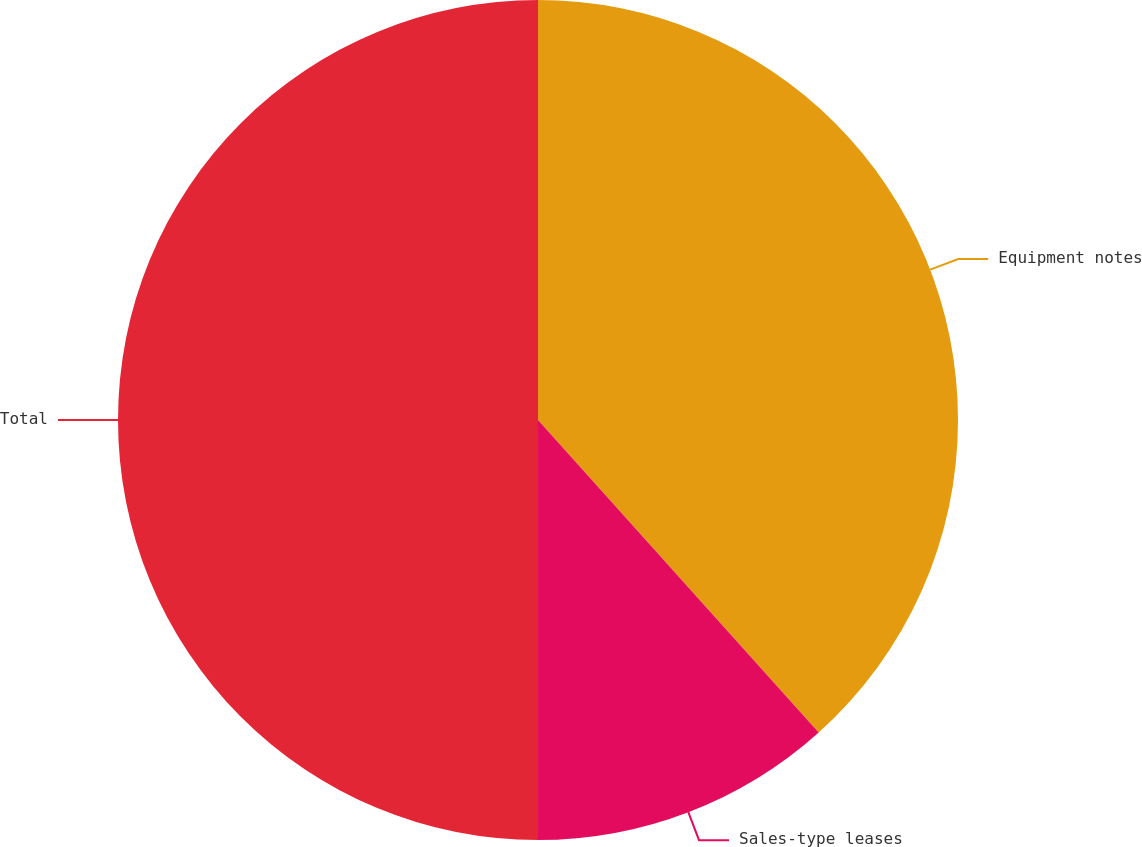Convert chart. <chart><loc_0><loc_0><loc_500><loc_500><pie_chart><fcel>Equipment notes<fcel>Sales-type leases<fcel>Total<nl><fcel>38.35%<fcel>11.65%<fcel>50.0%<nl></chart> 